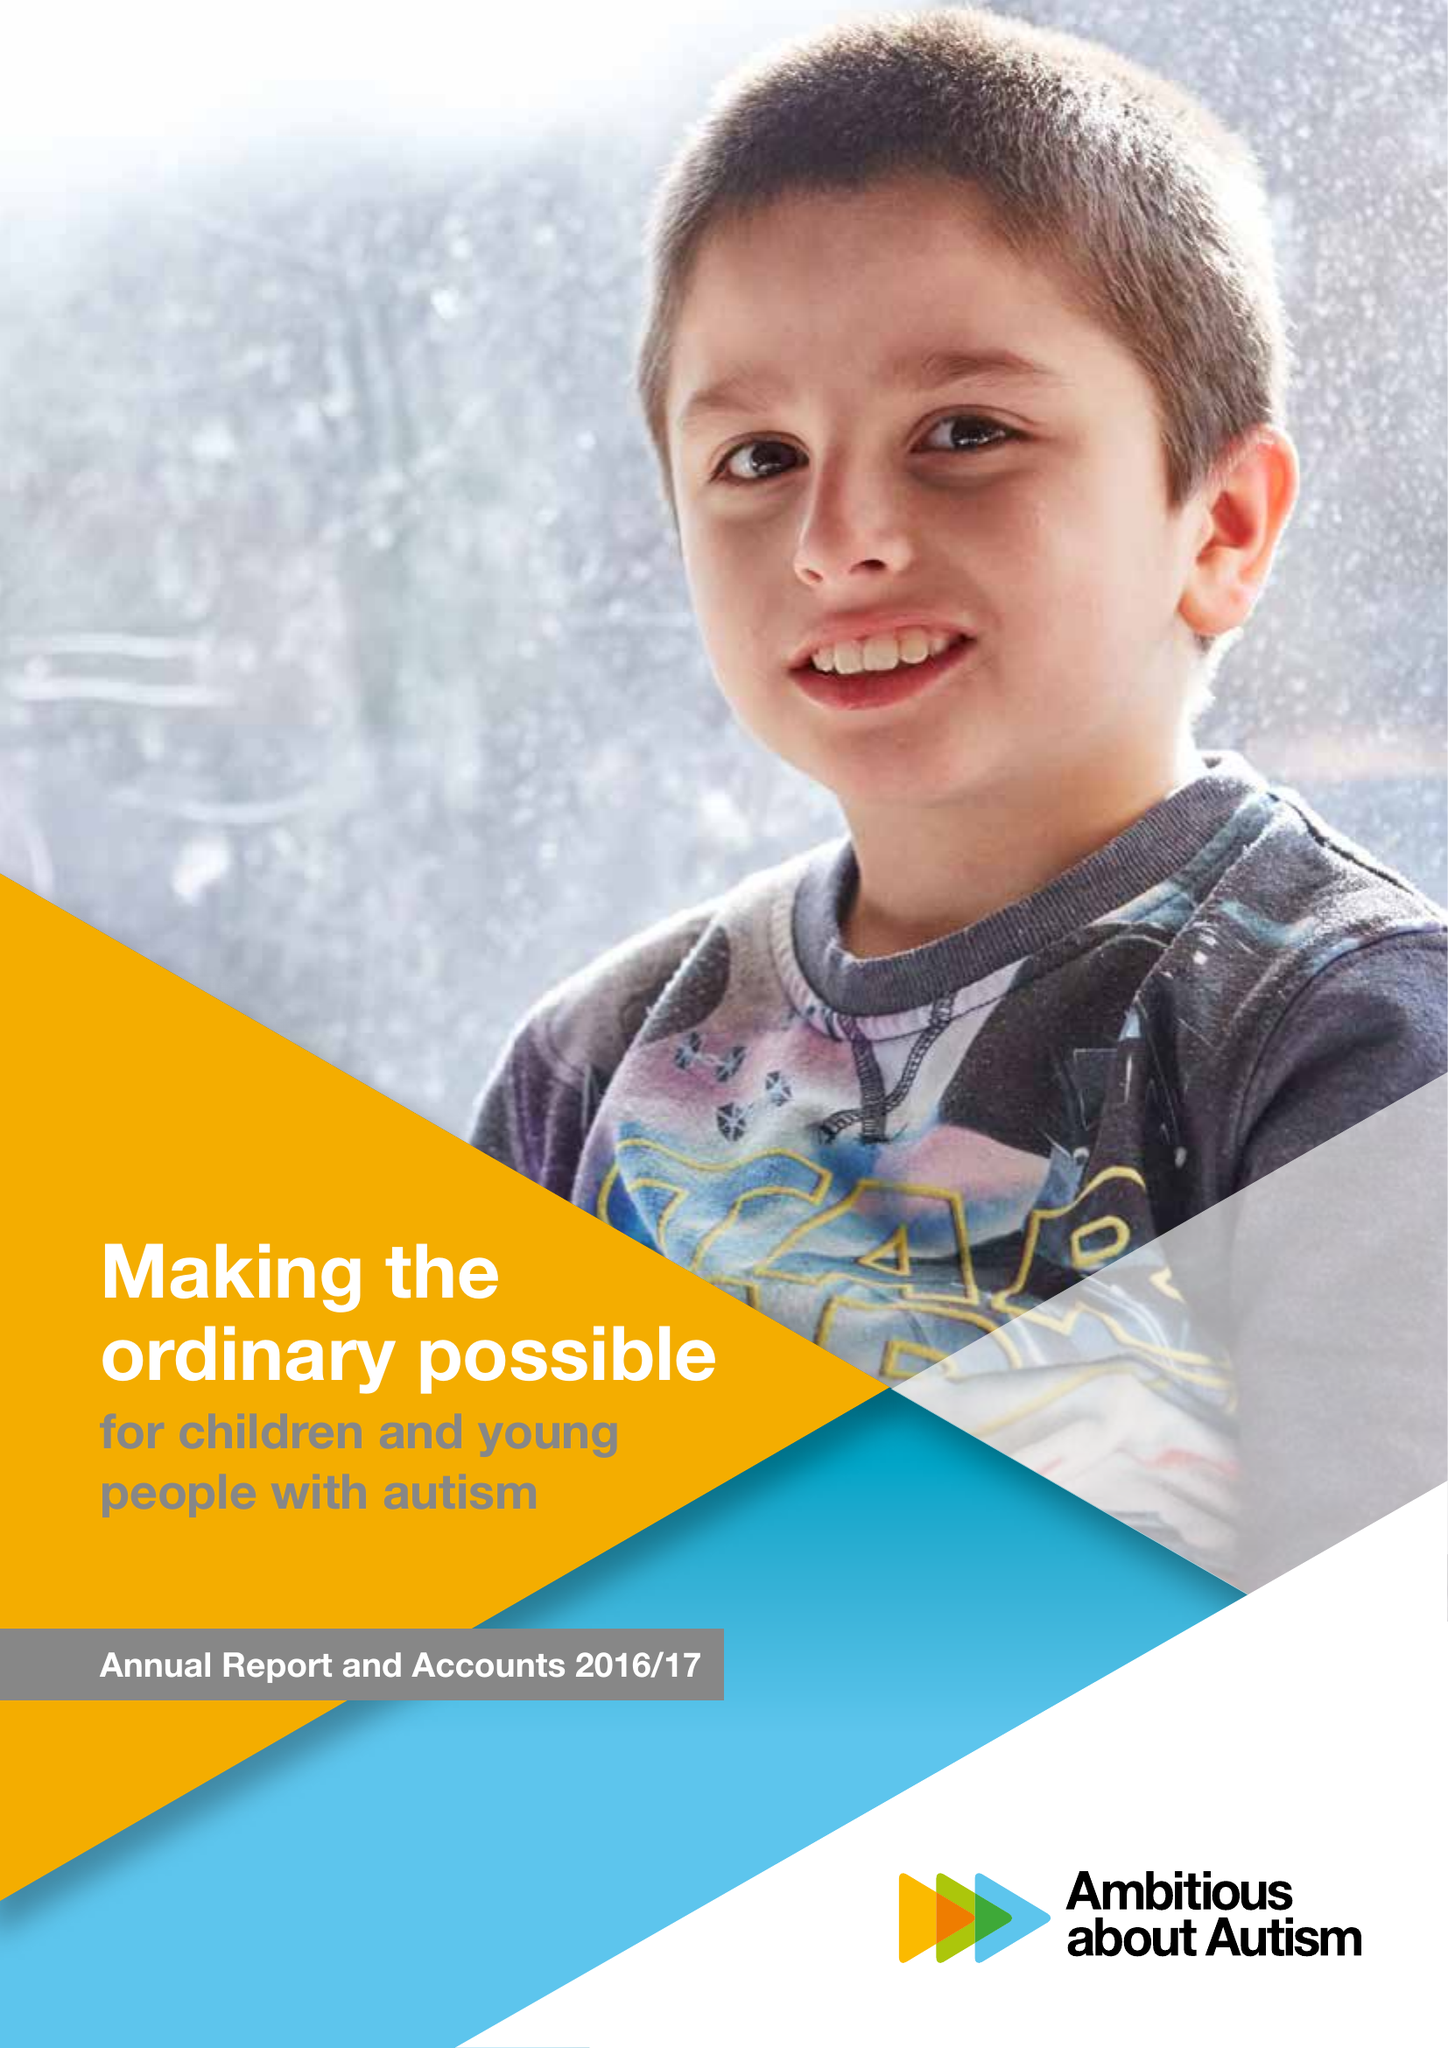What is the value for the address__street_line?
Answer the question using a single word or phrase. WOODSIDE AVENUE 